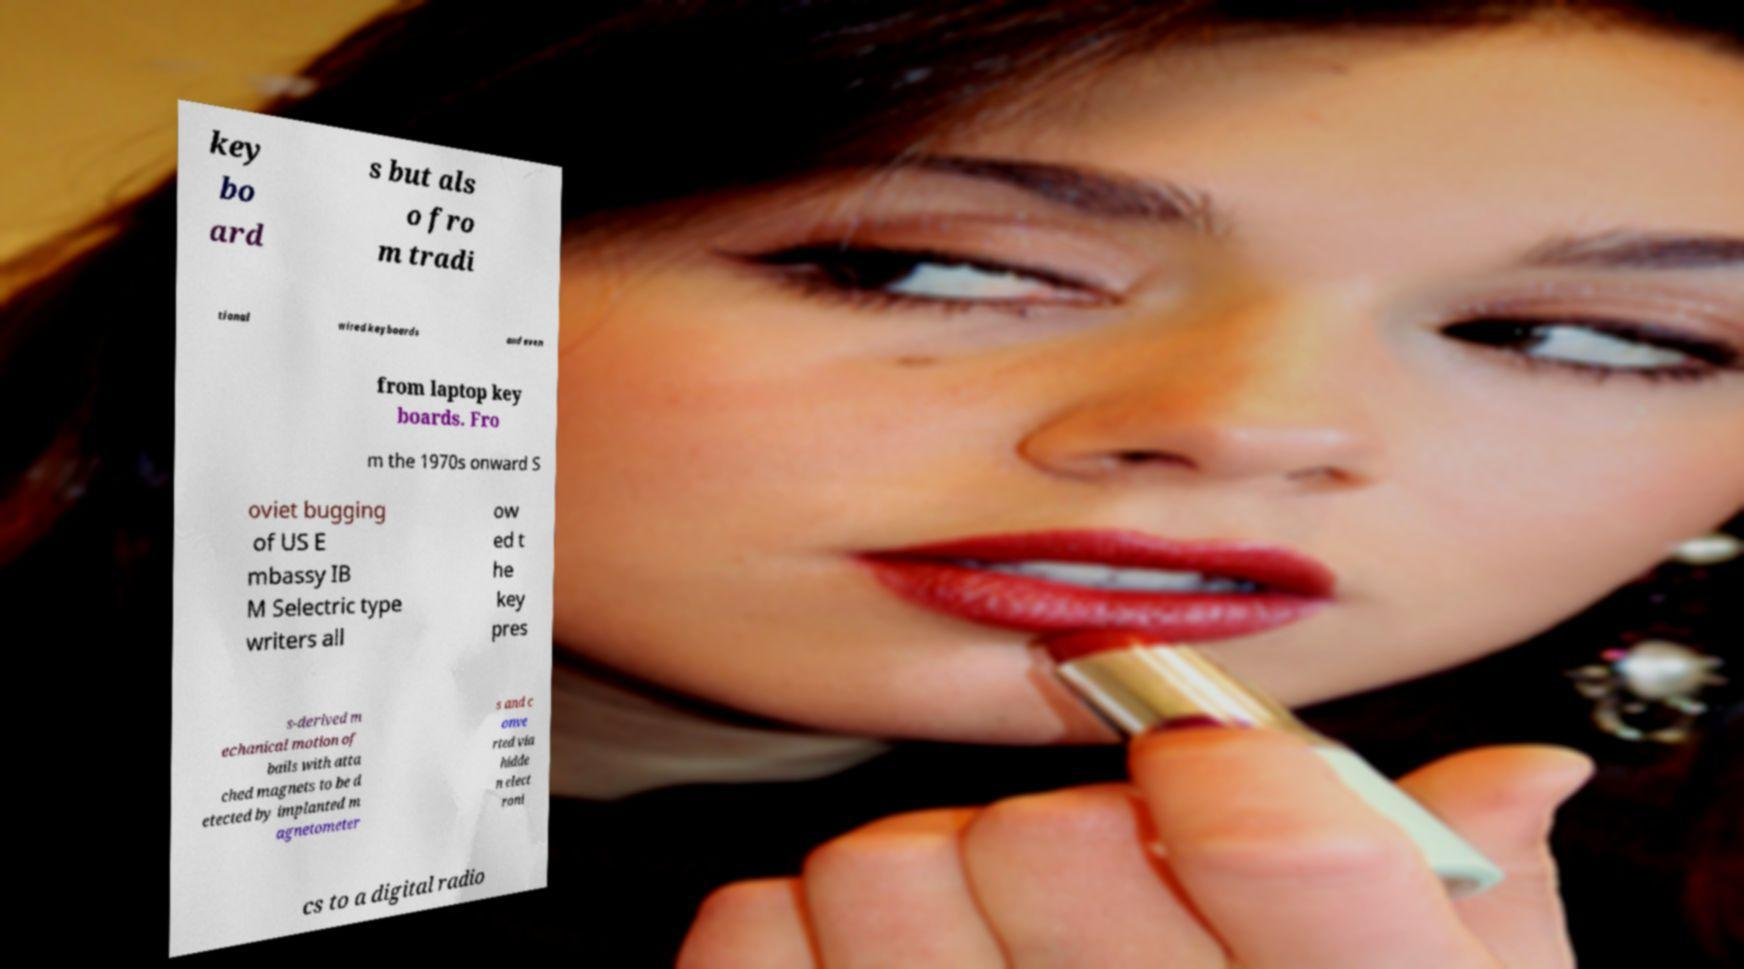Can you accurately transcribe the text from the provided image for me? key bo ard s but als o fro m tradi tional wired keyboards and even from laptop key boards. Fro m the 1970s onward S oviet bugging of US E mbassy IB M Selectric type writers all ow ed t he key pres s-derived m echanical motion of bails with atta ched magnets to be d etected by implanted m agnetometer s and c onve rted via hidde n elect roni cs to a digital radio 